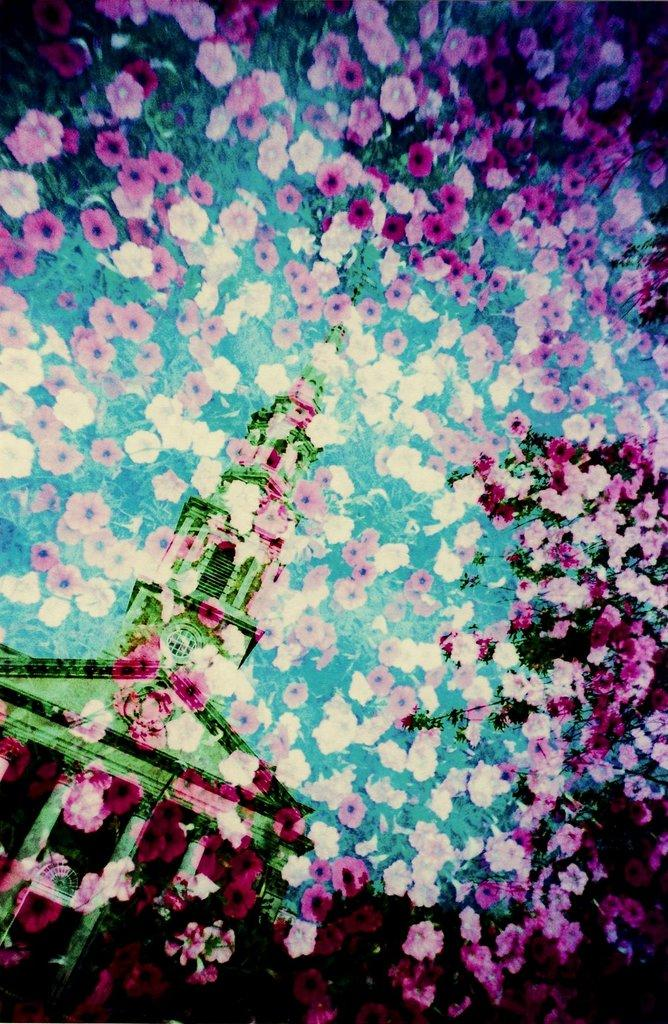What type of editing has been done to the image? The image is edited, but the specific type of editing is not mentioned in the facts. What can be seen in the foreground of the image? There are flowers in the foreground of the image. What is visible in the background of the image? There is a building in the background of the image. What name is written on the veil in the image? There is no veil present in the image, so it is not possible to answer that question. 